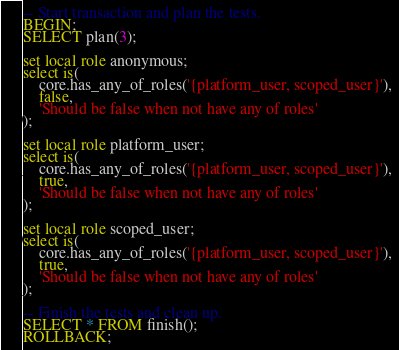Convert code to text. <code><loc_0><loc_0><loc_500><loc_500><_SQL_>-- Start transaction and plan the tests.
BEGIN;
SELECT plan(3);

set local role anonymous;
select is(
    core.has_any_of_roles('{platform_user, scoped_user}'),
    false,
    'Should be false when not have any of roles'
);

set local role platform_user;
select is(
    core.has_any_of_roles('{platform_user, scoped_user}'),
    true,
    'Should be false when not have any of roles'
);

set local role scoped_user;
select is(
    core.has_any_of_roles('{platform_user, scoped_user}'),
    true,
    'Should be false when not have any of roles'
);

-- Finish the tests and clean up.
SELECT * FROM finish();
ROLLBACK;


</code> 